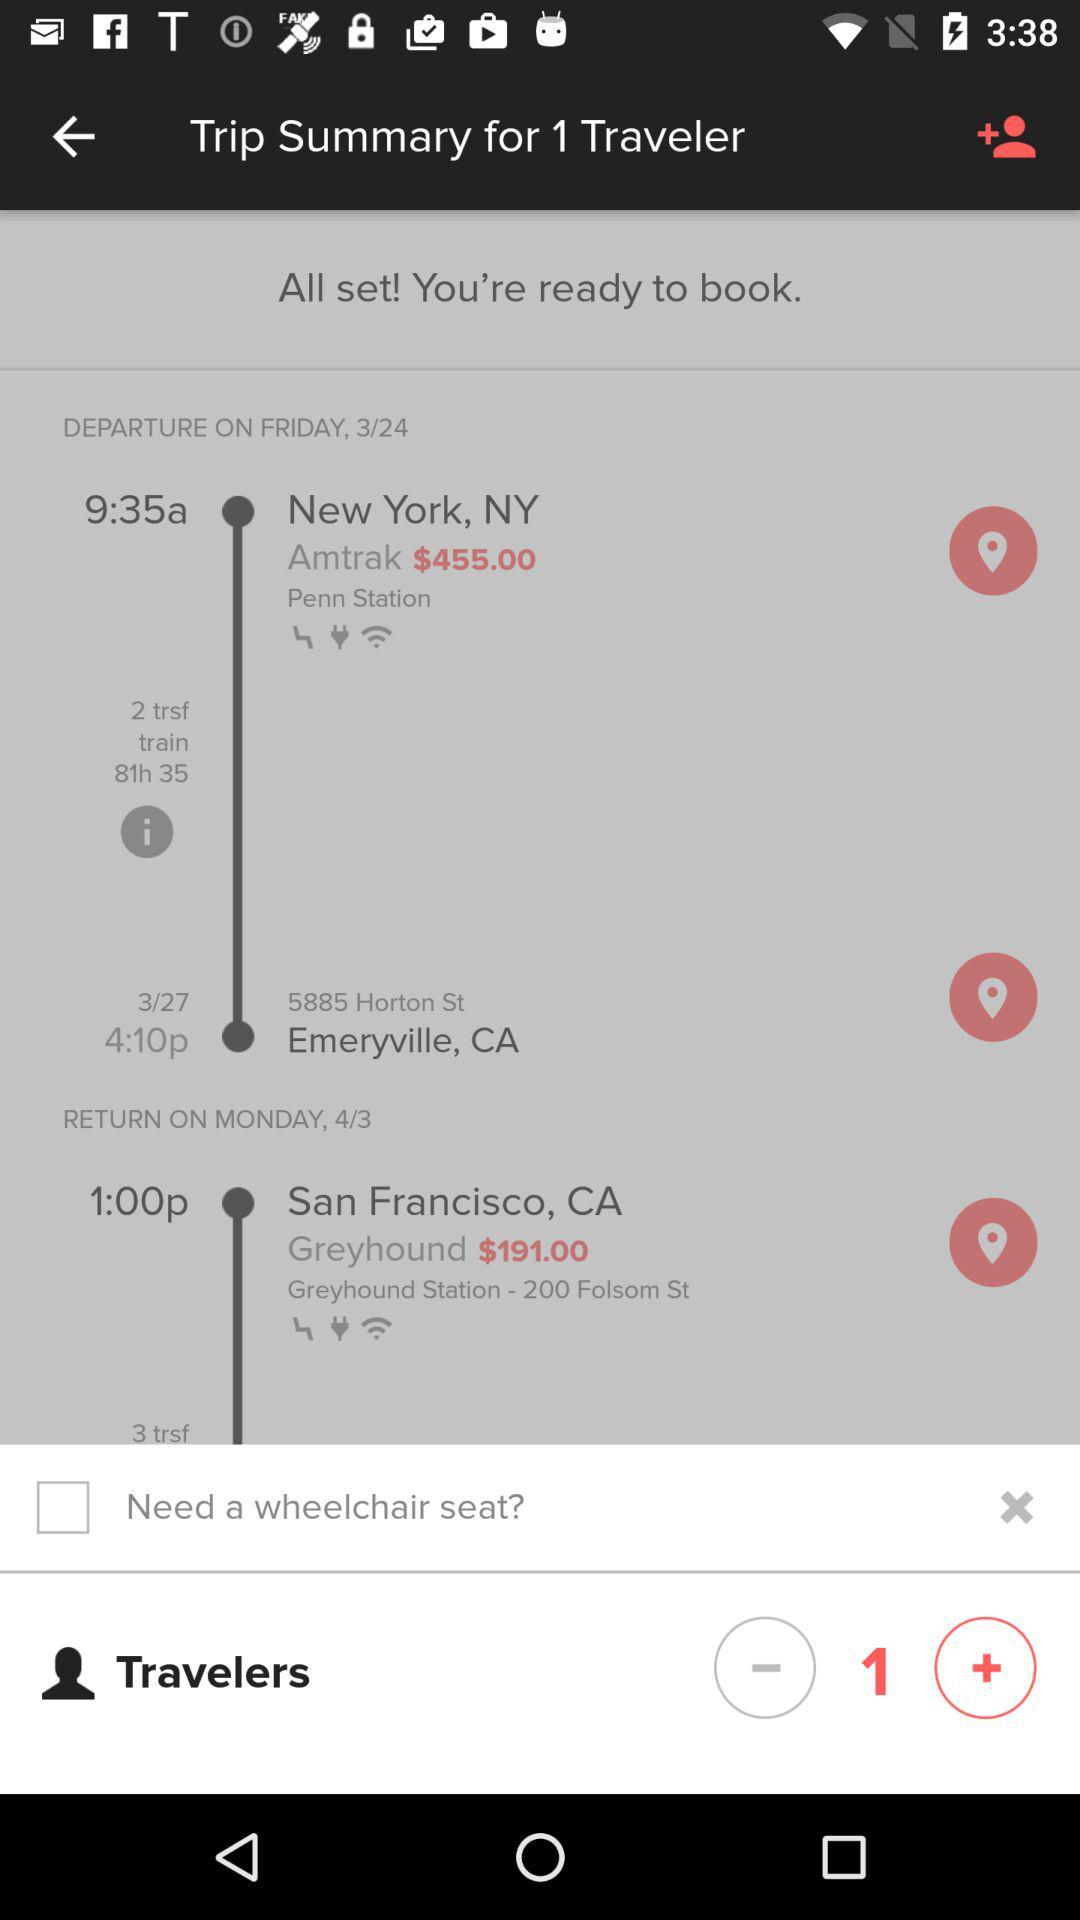When is the train supposed to leave from New York? The train is supposed to leave New York at 9:35 AM. 